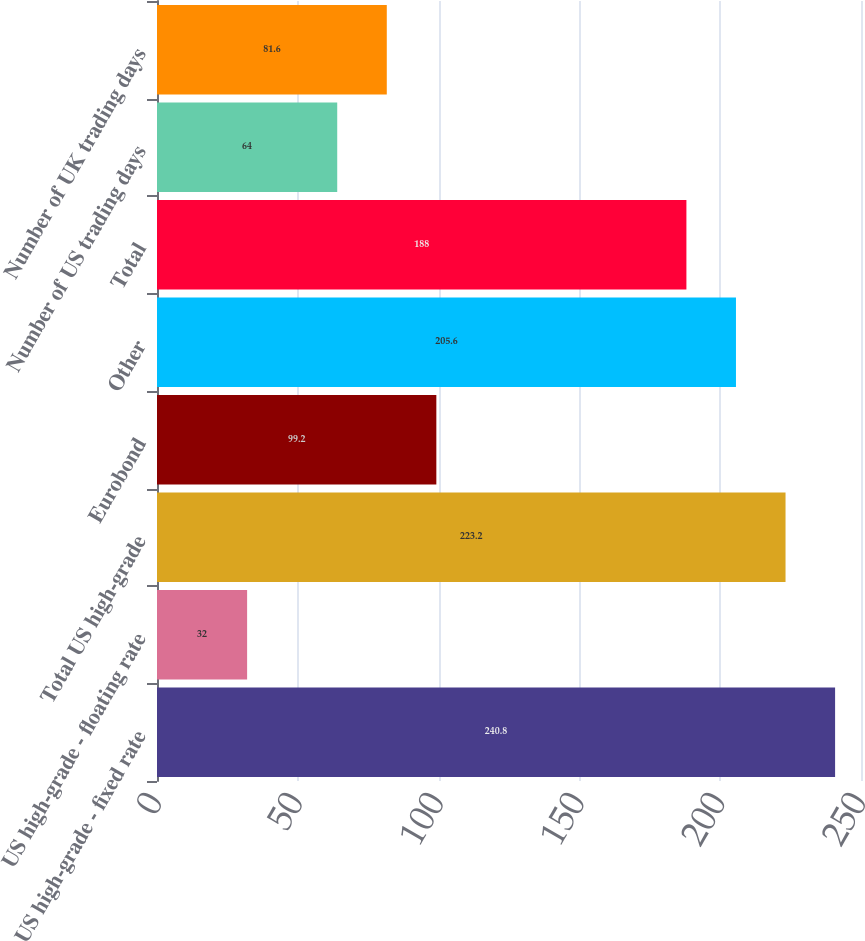Convert chart. <chart><loc_0><loc_0><loc_500><loc_500><bar_chart><fcel>US high-grade - fixed rate<fcel>US high-grade - floating rate<fcel>Total US high-grade<fcel>Eurobond<fcel>Other<fcel>Total<fcel>Number of US trading days<fcel>Number of UK trading days<nl><fcel>240.8<fcel>32<fcel>223.2<fcel>99.2<fcel>205.6<fcel>188<fcel>64<fcel>81.6<nl></chart> 